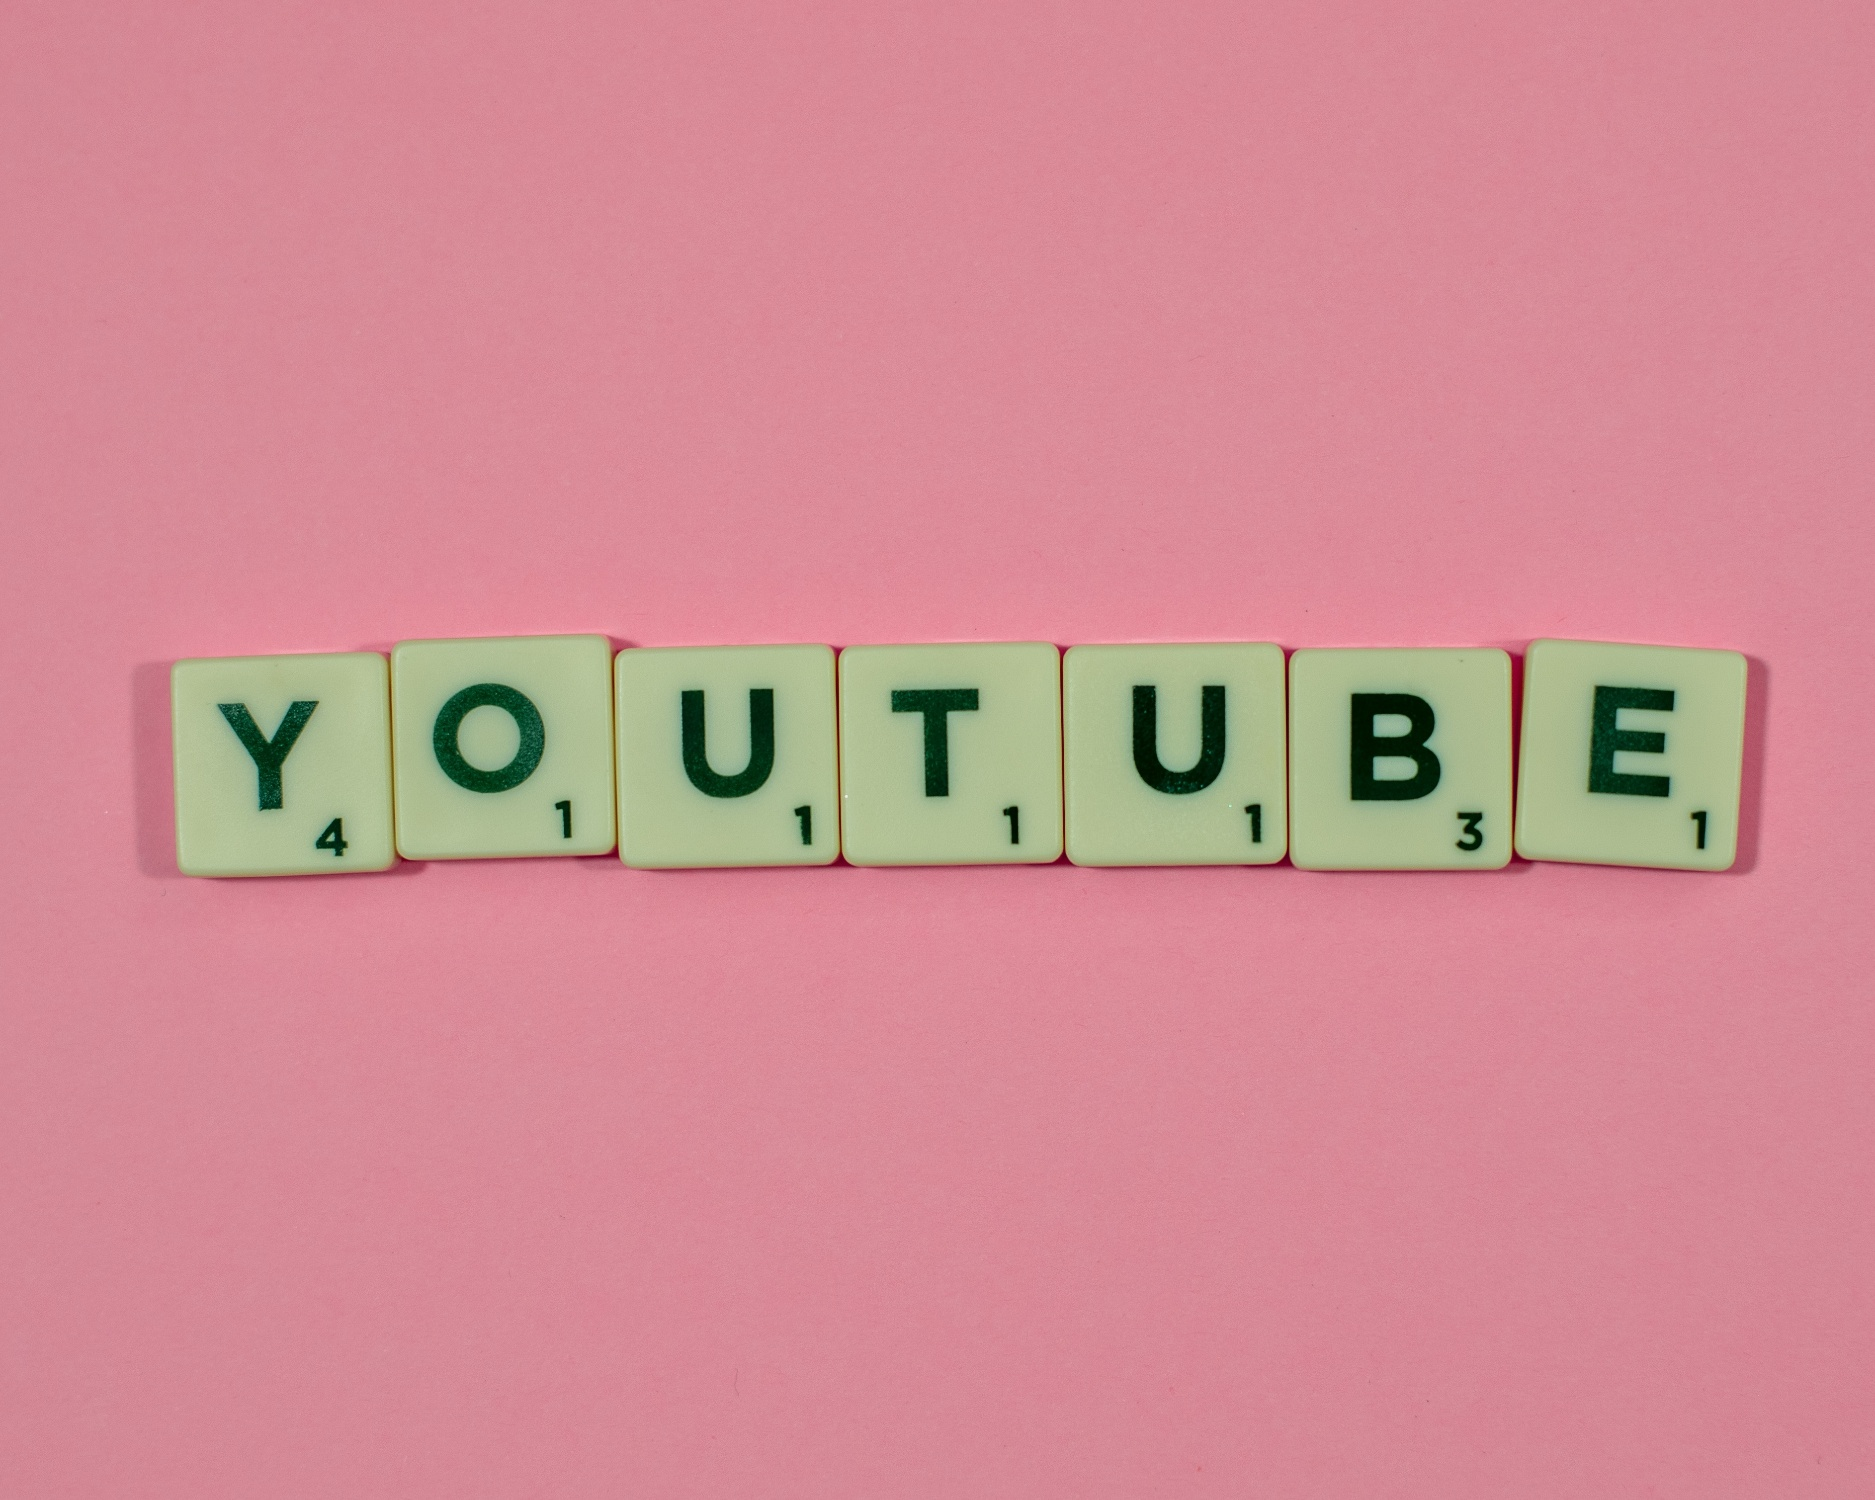Can you describe the mood or emotion this image might convey? The vibrant pink background and the meticulous arrangement of Scrabble tiles spelling 'YOUTUBE' evoke a sense of playfulness and creativity. The bright colors and familiar game elements suggest a fun, light-hearted atmosphere. It's an image that might make one feel excited and inspired, reminiscent of the joy found in playful activities and creative endeavors. 